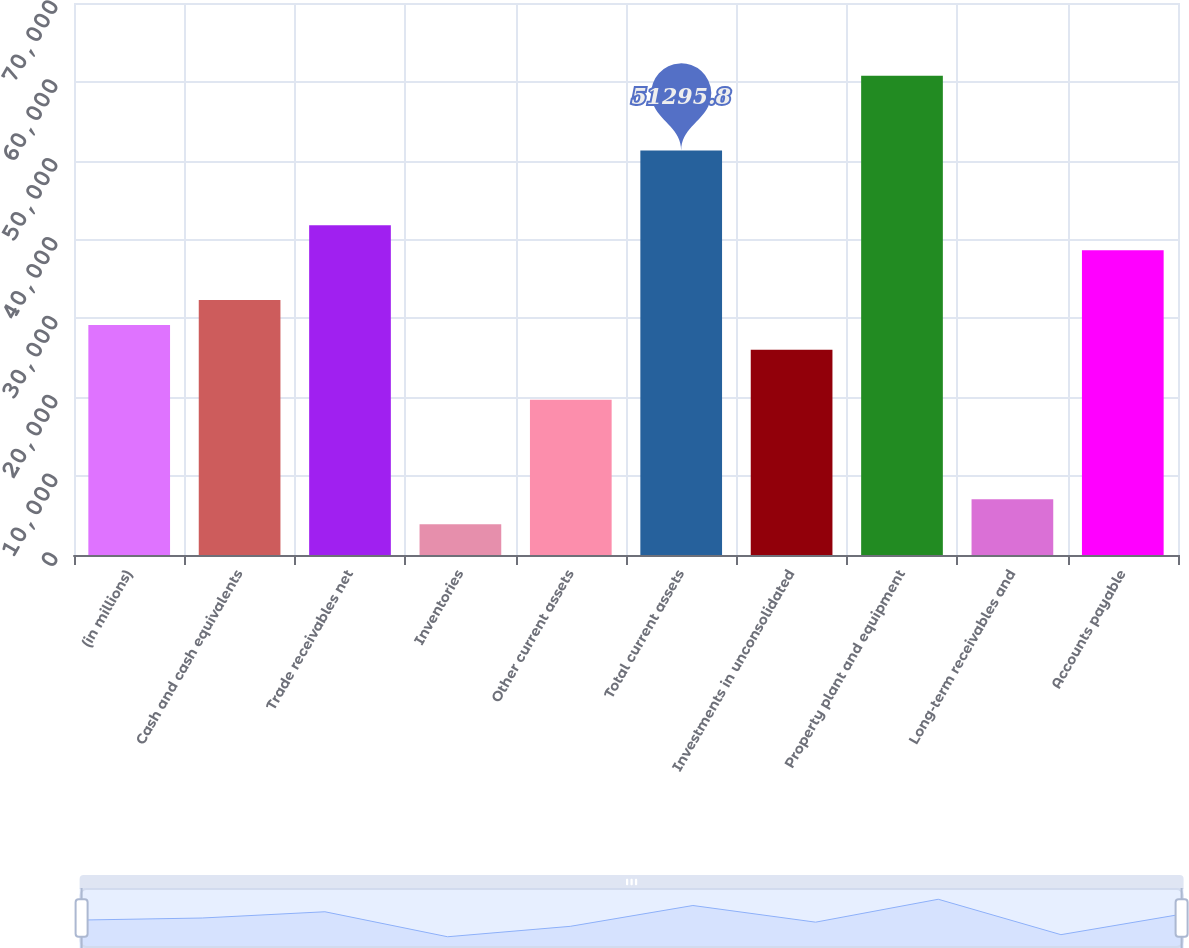<chart> <loc_0><loc_0><loc_500><loc_500><bar_chart><fcel>(in millions)<fcel>Cash and cash equivalents<fcel>Trade receivables net<fcel>Inventories<fcel>Other current assets<fcel>Total current assets<fcel>Investments in unconsolidated<fcel>Property plant and equipment<fcel>Long-term receivables and<fcel>Accounts payable<nl><fcel>29177.2<fcel>32337<fcel>41816.4<fcel>3898.8<fcel>19697.8<fcel>51295.8<fcel>26017.4<fcel>60775.2<fcel>7058.6<fcel>38656.6<nl></chart> 